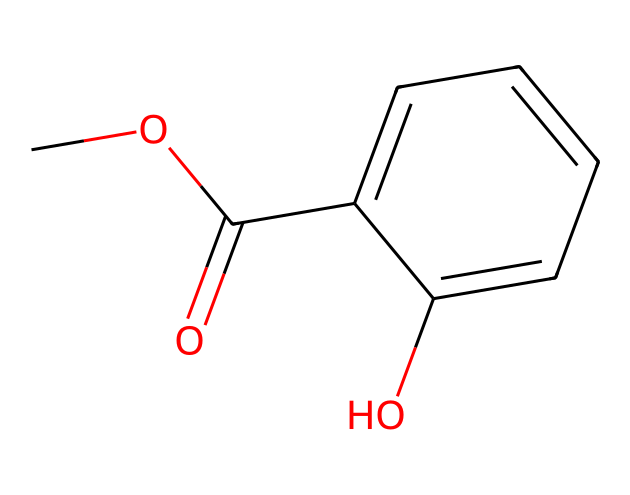How many carbon atoms are in methyl salicylate? The chemical structure indicates that there are six carbon atoms (C). This can be counted directly from the representation: there are four in the aromatic ring (C1=CC=CC=C1) and two in the ester group (COC(=O)).
Answer: six What is the functional group present in methyl salicylate? The chemical includes an ester functional group indicated by the C(=O)O component connected to a methyl group (CO-). This matches the characteristic structure of esters.
Answer: ester How many hydrogen atoms are present in methyl salicylate? To find the number of hydrogen atoms, we summarize the various parts of the molecule: The aromatic ring contributes four hydrogen atoms, and the methyl group (CO) contributes three. Altogether, there are six hydrogen atoms in total, as it is a saturated compound.
Answer: six What is the largest ring structure present in methyl salicylate? The chemical includes a benzene ring, which has six carbon atoms in a cyclic arrangement, corresponding to the formula C6H5, making it the largest ring structure.
Answer: benzene What type of aromatic compound comprises the ring in methyl salicylate? The ring in methyl salicylate is a phenolic compound due to the presence of the hydroxyl group (O) bonded directly to the aromatic ring. This gives it specific properties associated with phenols.
Answer: phenolic 